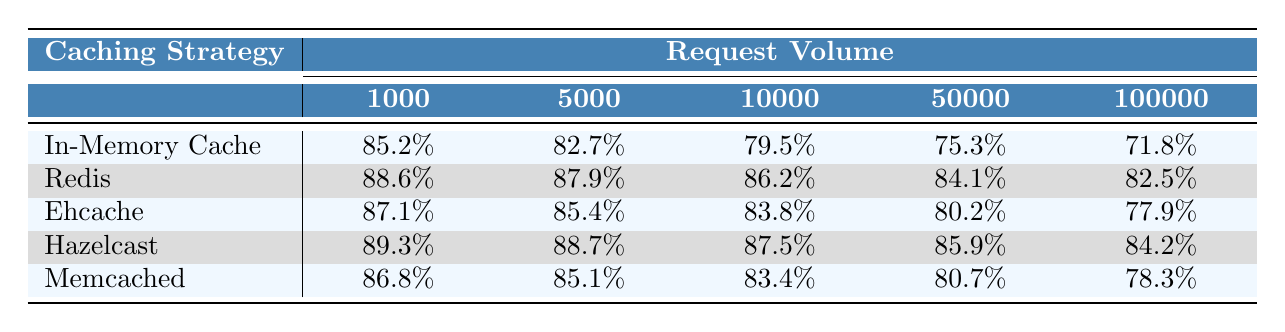What is the cache hit rate for the Redis strategy at a request volume of 10,000? The table shows the hit rate for Redis at a request volume of 10,000 as 86.2%.
Answer: 86.2% Which caching strategy has the highest hit rate at a request volume of 1,000? By looking at the first column of the table, Hazelcast has the highest hit rate at 89.3%.
Answer: Hazelcast What is the average cache hit rate for the In-Memory Cache across all request volumes? The hit rates for In-Memory Cache are 85.2%, 82.7%, 79.5%, 75.3%, and 71.8%. Summing these values gives 394.5%, and dividing by 5 yields an average of 78.9%.
Answer: 78.9% Is the hit rate for Memcached at 50,000 requests higher than that for Ehcache at the same volume? The hit rate for Memcached at 50,000 requests is 80.7%, while for Ehcache it is 80.2%. Since 80.7% is greater than 80.2%, the statement is true.
Answer: Yes Which caching strategy shows the least decline in hit rate from 1,000 to 100,000 requests? The decline can be measured by subtracting the hit rates at 1,000 from those at 100,000 for each strategy. The In-Memory Cache declines by 13.4%, Redis by 6.1%, Ehcache by 9.2%, Hazelcast declines by 5.1%, and Memcached declines by 8.5%. The least decline is for Hazelcast at 5.1%.
Answer: Hazelcast At a request volume of 5,000, which two strategies have hit rates within 1% of each other? The hit rates at 5,000 request volume are 82.7% (In-Memory Cache) and 82.5% (Redis). The difference is 0.2%, meaning they are within 1% of each other.
Answer: In-Memory Cache and Redis Which caching strategy has a consistent decline in hit rate as the request volume increases? Looking at the hit rates, all strategies show a decline, but In-Memory Cache shows a consistently decreasing trend from 85.2% to 71.8%.
Answer: In-Memory Cache What is the difference in hit rates between Redis and Hazelcast at a request volume of 100,000? At 100,000 requests, Redis has a hit rate of 82.5%, and Hazelcast has 84.2%. The difference is calculated as 84.2% - 82.5% = 1.7%.
Answer: 1.7% 